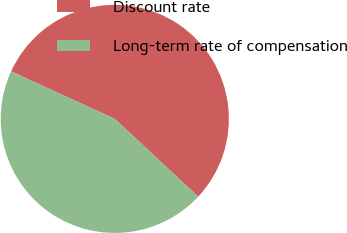Convert chart. <chart><loc_0><loc_0><loc_500><loc_500><pie_chart><fcel>Discount rate<fcel>Long-term rate of compensation<nl><fcel>55.1%<fcel>44.9%<nl></chart> 